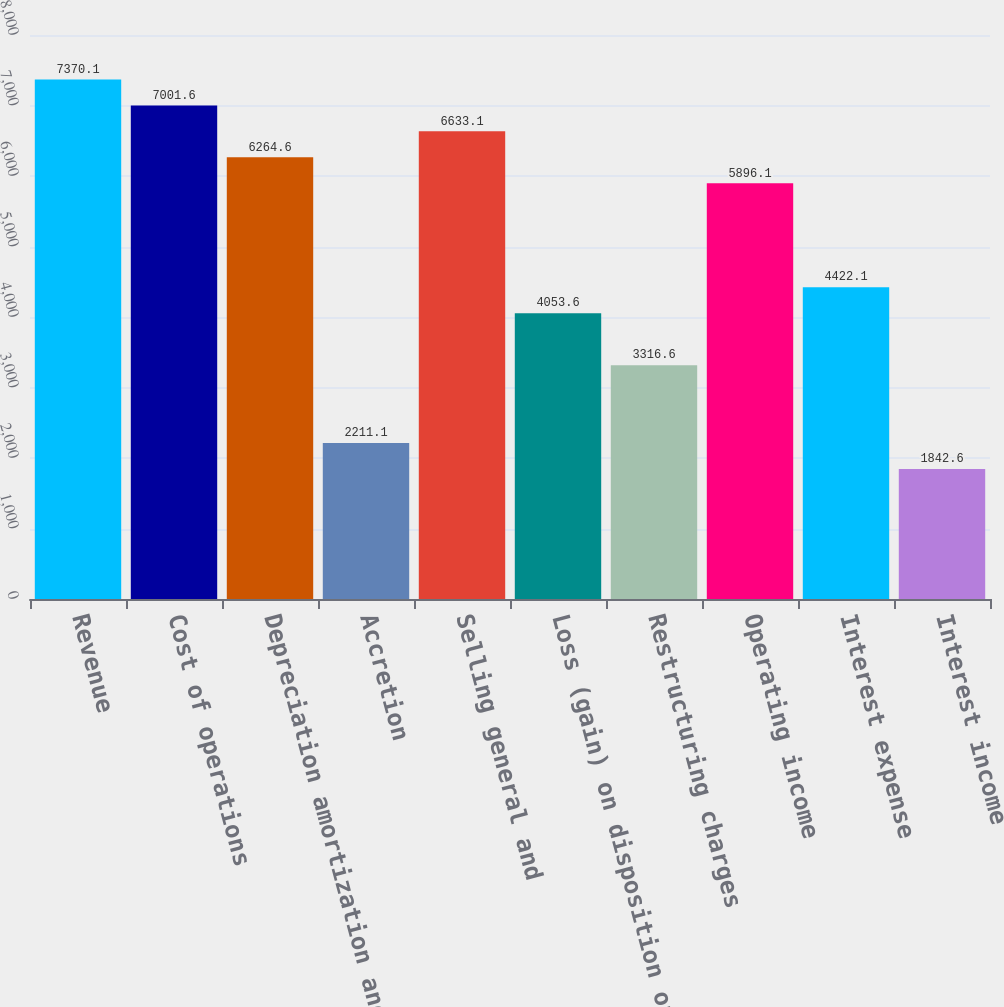Convert chart. <chart><loc_0><loc_0><loc_500><loc_500><bar_chart><fcel>Revenue<fcel>Cost of operations<fcel>Depreciation amortization and<fcel>Accretion<fcel>Selling general and<fcel>Loss (gain) on disposition of<fcel>Restructuring charges<fcel>Operating income<fcel>Interest expense<fcel>Interest income<nl><fcel>7370.1<fcel>7001.6<fcel>6264.6<fcel>2211.1<fcel>6633.1<fcel>4053.6<fcel>3316.6<fcel>5896.1<fcel>4422.1<fcel>1842.6<nl></chart> 